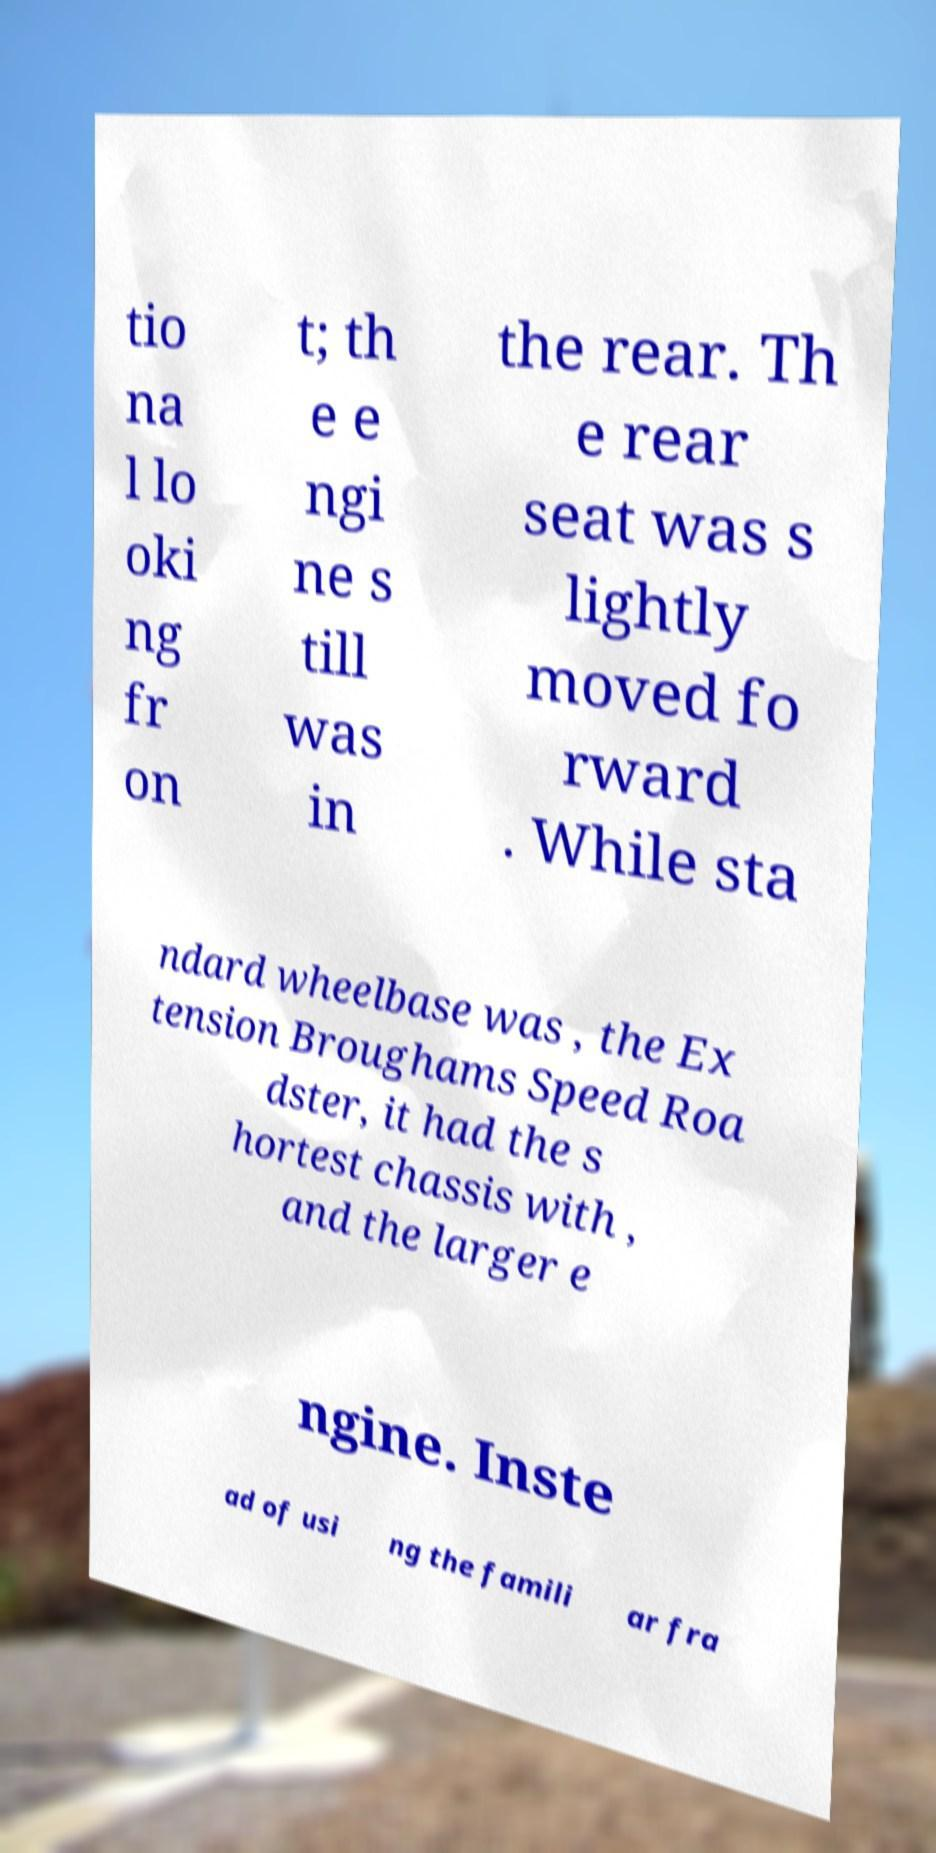Can you accurately transcribe the text from the provided image for me? tio na l lo oki ng fr on t; th e e ngi ne s till was in the rear. Th e rear seat was s lightly moved fo rward . While sta ndard wheelbase was , the Ex tension Broughams Speed Roa dster, it had the s hortest chassis with , and the larger e ngine. Inste ad of usi ng the famili ar fra 